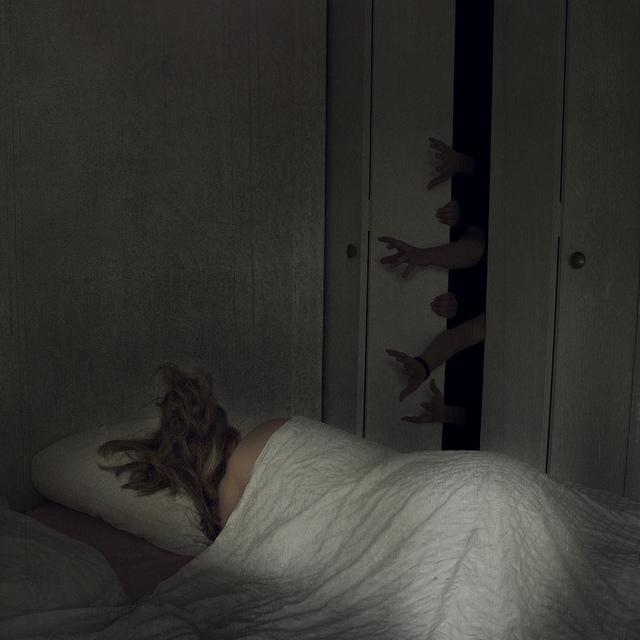What are coming out of the closet? hands 